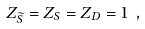Convert formula to latex. <formula><loc_0><loc_0><loc_500><loc_500>Z _ { \widetilde { S } } = Z _ { S } = Z _ { D } = 1 \ ,</formula> 